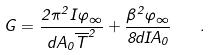<formula> <loc_0><loc_0><loc_500><loc_500>G = \frac { 2 \pi ^ { 2 } I \varphi _ { \infty } } { d A _ { 0 } { \overline { T } } ^ { 2 } } + \frac { \beta ^ { 2 } \varphi _ { \infty } } { 8 d I A _ { 0 } } \quad .</formula> 